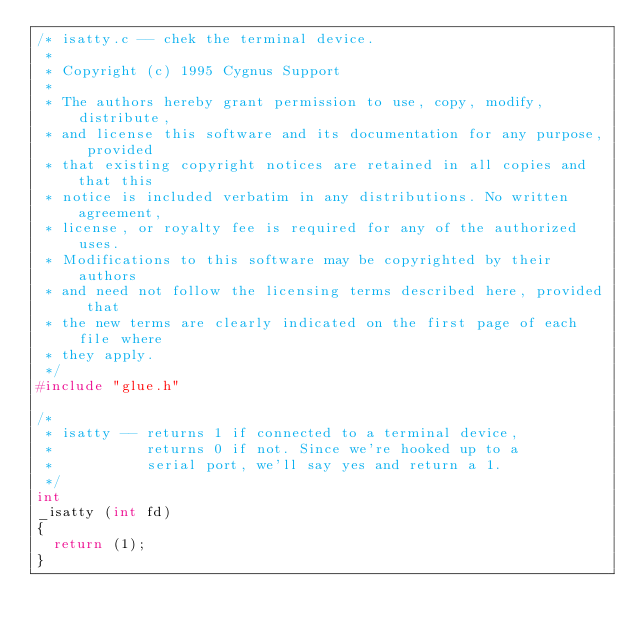Convert code to text. <code><loc_0><loc_0><loc_500><loc_500><_C_>/* isatty.c -- chek the terminal device.
 * 
 * Copyright (c) 1995 Cygnus Support
 *
 * The authors hereby grant permission to use, copy, modify, distribute,
 * and license this software and its documentation for any purpose, provided
 * that existing copyright notices are retained in all copies and that this
 * notice is included verbatim in any distributions. No written agreement,
 * license, or royalty fee is required for any of the authorized uses.
 * Modifications to this software may be copyrighted by their authors
 * and need not follow the licensing terms described here, provided that
 * the new terms are clearly indicated on the first page of each file where
 * they apply.
 */
#include "glue.h"

/*
 * isatty -- returns 1 if connected to a terminal device,
 *           returns 0 if not. Since we're hooked up to a
 *           serial port, we'll say yes and return a 1.
 */
int
_isatty (int fd)
{
  return (1);
}
</code> 